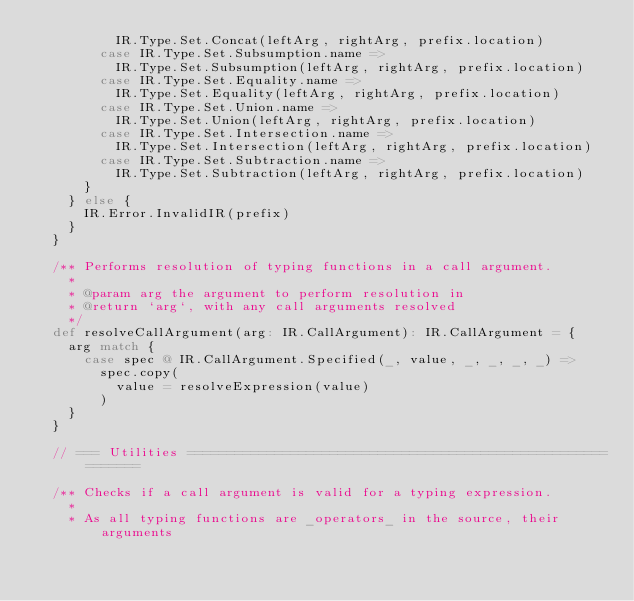Convert code to text. <code><loc_0><loc_0><loc_500><loc_500><_Scala_>          IR.Type.Set.Concat(leftArg, rightArg, prefix.location)
        case IR.Type.Set.Subsumption.name =>
          IR.Type.Set.Subsumption(leftArg, rightArg, prefix.location)
        case IR.Type.Set.Equality.name =>
          IR.Type.Set.Equality(leftArg, rightArg, prefix.location)
        case IR.Type.Set.Union.name =>
          IR.Type.Set.Union(leftArg, rightArg, prefix.location)
        case IR.Type.Set.Intersection.name =>
          IR.Type.Set.Intersection(leftArg, rightArg, prefix.location)
        case IR.Type.Set.Subtraction.name =>
          IR.Type.Set.Subtraction(leftArg, rightArg, prefix.location)
      }
    } else {
      IR.Error.InvalidIR(prefix)
    }
  }

  /** Performs resolution of typing functions in a call argument.
    *
    * @param arg the argument to perform resolution in
    * @return `arg`, with any call arguments resolved
    */
  def resolveCallArgument(arg: IR.CallArgument): IR.CallArgument = {
    arg match {
      case spec @ IR.CallArgument.Specified(_, value, _, _, _, _) =>
        spec.copy(
          value = resolveExpression(value)
        )
    }
  }

  // === Utilities ============================================================

  /** Checks if a call argument is valid for a typing expression.
    *
    * As all typing functions are _operators_ in the source, their arguments</code> 